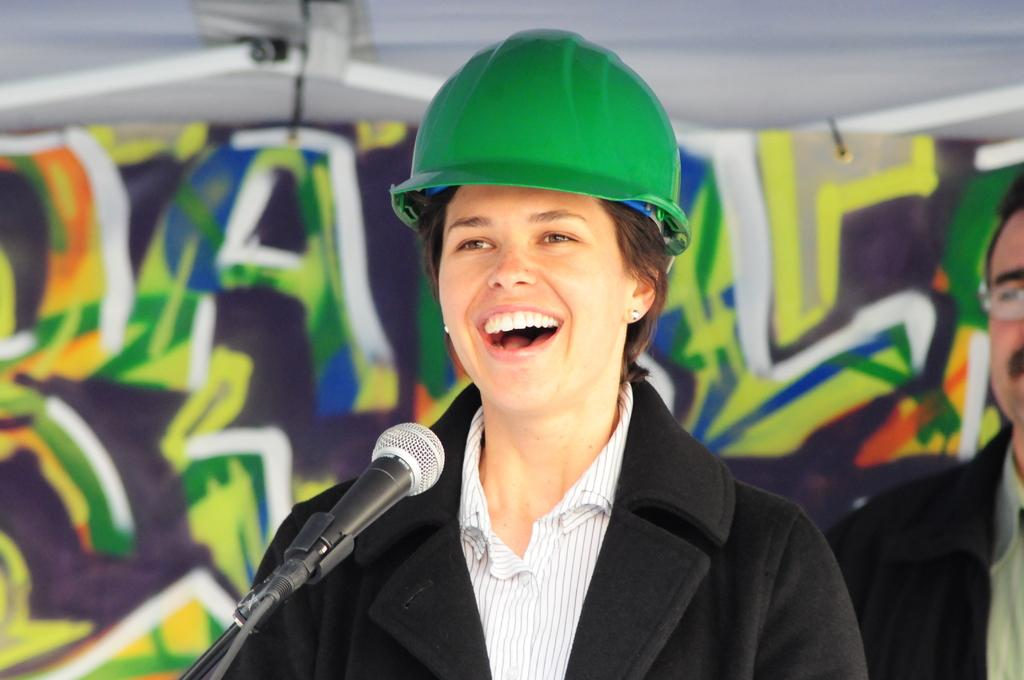What is the main subject of the image? There is a person in the image. What is the person wearing? The person is wearing a black and white dress. What object is in front of the person? There is a microphone in front of the person. What can be seen in the background of the image? The background of the image includes a multi-color wall. What color is the roof in the image? The roof in the image is white. What type of stick can be seen in the person's hand in the image? There is no stick present in the person's hand or in the image. What disease is the person suffering from in the image? There is no indication of any disease in the image; it only shows a person with a microphone in front of them. 